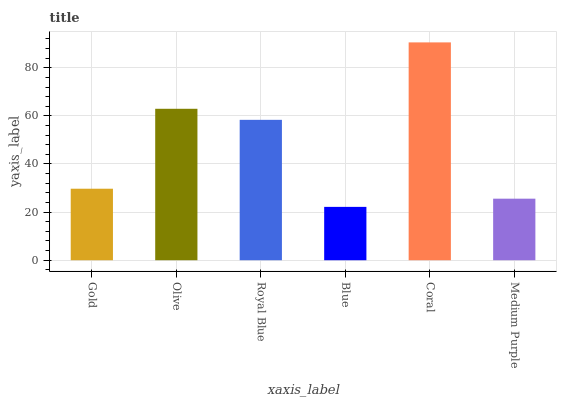Is Olive the minimum?
Answer yes or no. No. Is Olive the maximum?
Answer yes or no. No. Is Olive greater than Gold?
Answer yes or no. Yes. Is Gold less than Olive?
Answer yes or no. Yes. Is Gold greater than Olive?
Answer yes or no. No. Is Olive less than Gold?
Answer yes or no. No. Is Royal Blue the high median?
Answer yes or no. Yes. Is Gold the low median?
Answer yes or no. Yes. Is Olive the high median?
Answer yes or no. No. Is Royal Blue the low median?
Answer yes or no. No. 